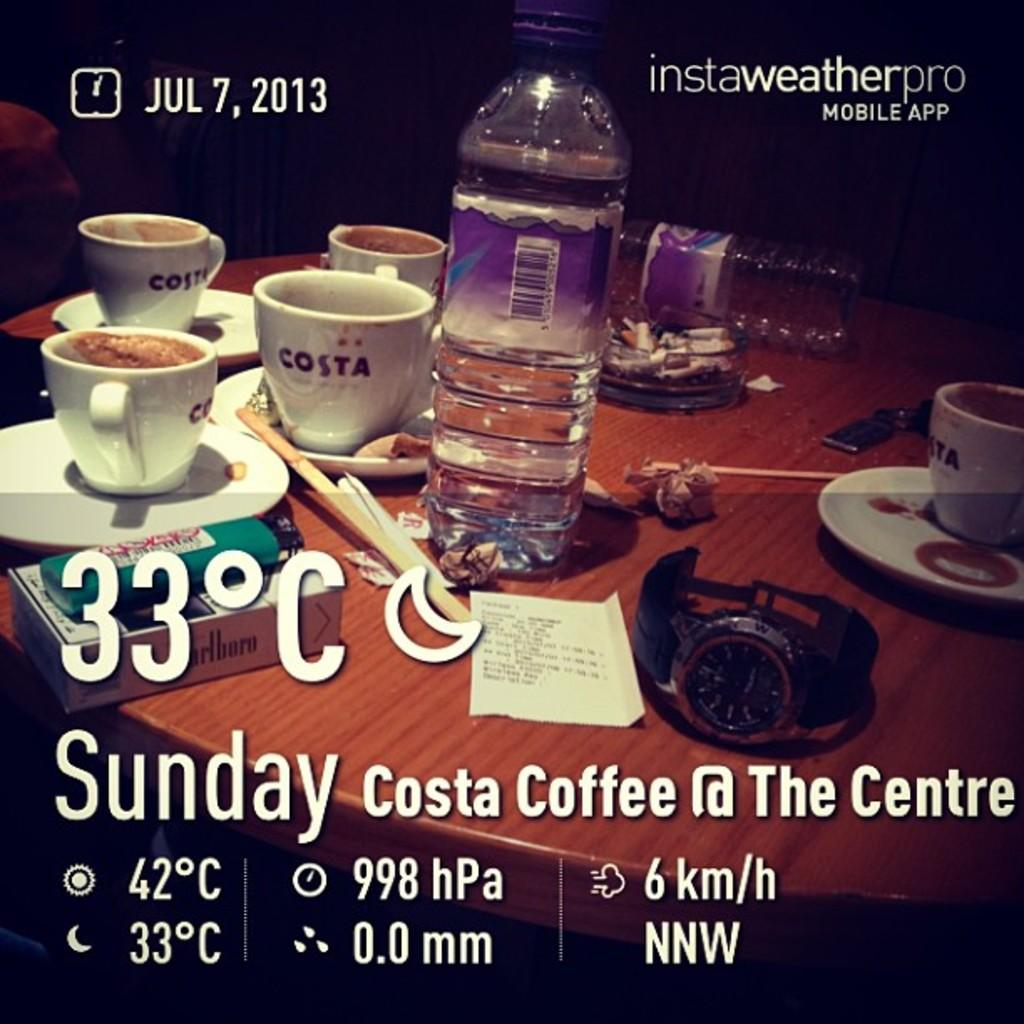<image>
Present a compact description of the photo's key features. A table with four white cups with word costa written on them. 